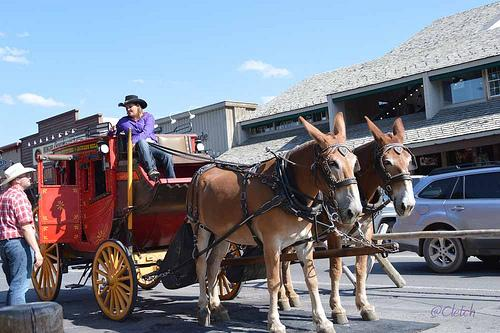What is unique about the woman mentioned in the image? The woman is wearing a black cowboy hat. Please enumerate the colors and details mentioned about the stagecoach. The stagecoach is red with flower designs and has an opened door and a yellow rod. Explain the appearance of one of the horses in the image. One of the horses is brown and white. Which two prominent colors are mentioned in the image related to people's clothing? Purple and red. Identify the main activity taking place in this image. Two horses are pulling a stagecoach replica down a city street. What color is the carriage in the image? The carriage is red. Describe any presence of a vehicle other than the stagecoach in the image. There is half of a silver car on a city street. What are the two different types of hats mentioned in the image? A white hat and a black cowboy hat. Provide information about the harness mentioned in the image. The harness is black and is used for the two horses pulling the stagecoach. Can you tell me anything about the wheel of the stagecoach? The front wheel of the stagecoach is yellow and black. What major event seems to be taking place in this scene? A stagecoach parade or performance involving horses and people in western outfits. Is there a green shirt on the person next to the stagecoach? The shirt colors described are purple and red, not green. What is the color of the carriage in this image? Red Observe the image and identify any highlighted text or printed words. No OCR-detected text in the image. Verify if the photo confirms this statement: "In the image, two horses are pulling a stagecoach driven by a woman wearing a black cowboy hat." Yes, the image visually supports that statement. Choose the correct description of the woman's hat in the image: white, black cowboy hat, or beige. Black cowboy hat Can you write an elaborate description of this image focusing on the horses? Two majestic brown and white horses are pulling an intricate red stagecoach replica as they gallop down a bustling city street, drawing attention and admiration from passersby. Examine the image and determine if it visually supports the following statement: "Horses and people are showcased in a lively scene involving a stagecoach." Yes, the image visually entails the described scene. Analyze any diagrams or unique visual patterns in this image. There are no clear diagrams in the image. Provide a brief but detailed description of the woman wearing a black cowboy hat. She is donning a black cowboy hat, sitting on a stagecoach, and possibly wearing plaid clothing. Is there a motorcycle on the city street next to the stagecoach? There is a silver car described on the city street, not a motorcycle. Is the chain on the stagecoach golden? The chain is described as gray, not golden. Does the woman have a green cowboy hat? The woman is described as either wearing a black cowboy hat or beige cowboy hat, not a green one. Analyze the photo and describe what activity the people and animals are partaking in. Two horses are pulling a stagecoach, and people are either riding the stagecoach or walking alongside it on a city street. Is the carriage blue with star designs? The carriage is described as red and has flower designs, not blue and with star designs. Provide a creative caption for the main object in this image. A vintage red stagecoach adorned with flowers speeds through a lively city street. Generate a haiku inspired by the visual elements in this photo. Horses gallop through, Which of these car colors can be seen in the image - silver, blue or black? Silver Are the mules white and wearing blue harnesses? The mules are described as brown, and the harness is black, not white mules and blue harnesses. 